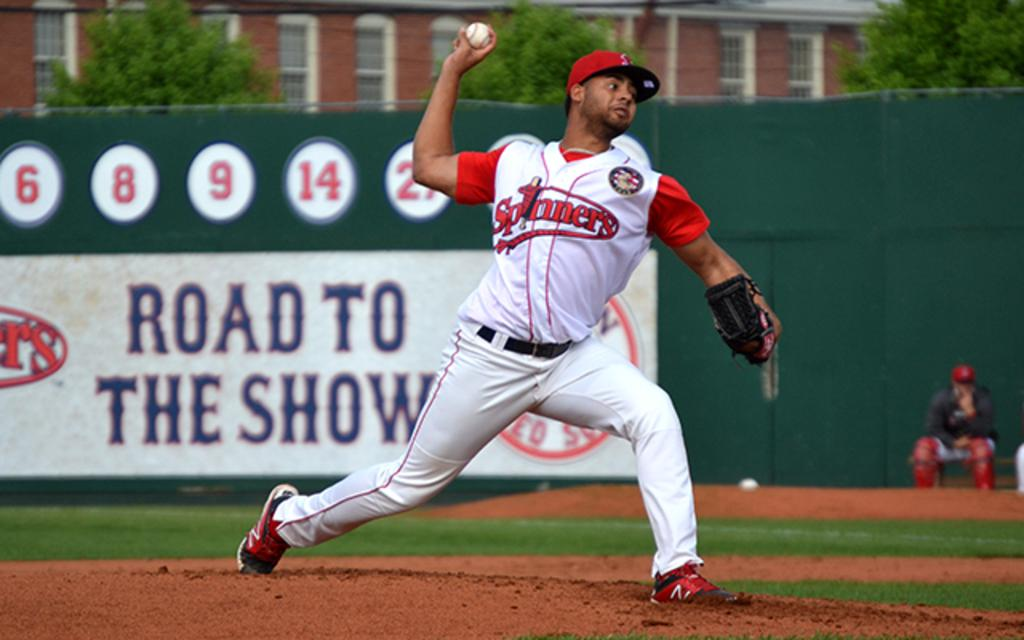<image>
Provide a brief description of the given image. The pitcher on the mound plays for the Spinners. 